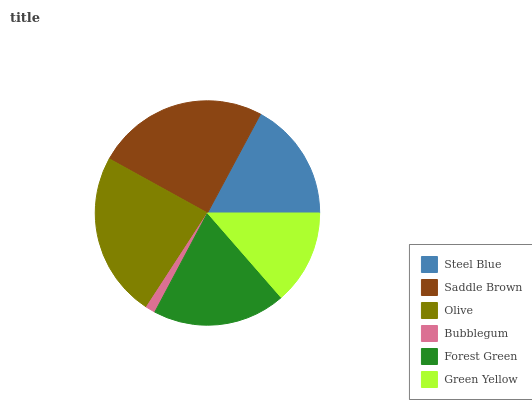Is Bubblegum the minimum?
Answer yes or no. Yes. Is Saddle Brown the maximum?
Answer yes or no. Yes. Is Olive the minimum?
Answer yes or no. No. Is Olive the maximum?
Answer yes or no. No. Is Saddle Brown greater than Olive?
Answer yes or no. Yes. Is Olive less than Saddle Brown?
Answer yes or no. Yes. Is Olive greater than Saddle Brown?
Answer yes or no. No. Is Saddle Brown less than Olive?
Answer yes or no. No. Is Forest Green the high median?
Answer yes or no. Yes. Is Steel Blue the low median?
Answer yes or no. Yes. Is Steel Blue the high median?
Answer yes or no. No. Is Olive the low median?
Answer yes or no. No. 